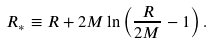Convert formula to latex. <formula><loc_0><loc_0><loc_500><loc_500>R _ { * } \equiv R + 2 M \ln \left ( \frac { R } { 2 M } - 1 \right ) .</formula> 